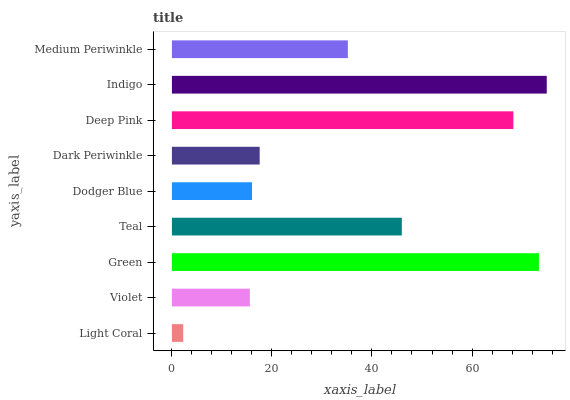Is Light Coral the minimum?
Answer yes or no. Yes. Is Indigo the maximum?
Answer yes or no. Yes. Is Violet the minimum?
Answer yes or no. No. Is Violet the maximum?
Answer yes or no. No. Is Violet greater than Light Coral?
Answer yes or no. Yes. Is Light Coral less than Violet?
Answer yes or no. Yes. Is Light Coral greater than Violet?
Answer yes or no. No. Is Violet less than Light Coral?
Answer yes or no. No. Is Medium Periwinkle the high median?
Answer yes or no. Yes. Is Medium Periwinkle the low median?
Answer yes or no. Yes. Is Dark Periwinkle the high median?
Answer yes or no. No. Is Dark Periwinkle the low median?
Answer yes or no. No. 